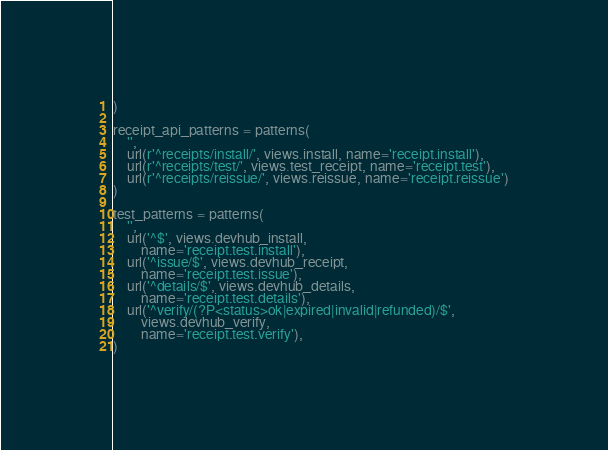Convert code to text. <code><loc_0><loc_0><loc_500><loc_500><_Python_>)

receipt_api_patterns = patterns(
    '',
    url(r'^receipts/install/', views.install, name='receipt.install'),
    url(r'^receipts/test/', views.test_receipt, name='receipt.test'),
    url(r'^receipts/reissue/', views.reissue, name='receipt.reissue')
)

test_patterns = patterns(
    '',
    url('^$', views.devhub_install,
        name='receipt.test.install'),
    url('^issue/$', views.devhub_receipt,
        name='receipt.test.issue'),
    url('^details/$', views.devhub_details,
        name='receipt.test.details'),
    url('^verify/(?P<status>ok|expired|invalid|refunded)/$',
        views.devhub_verify,
        name='receipt.test.verify'),
)
</code> 